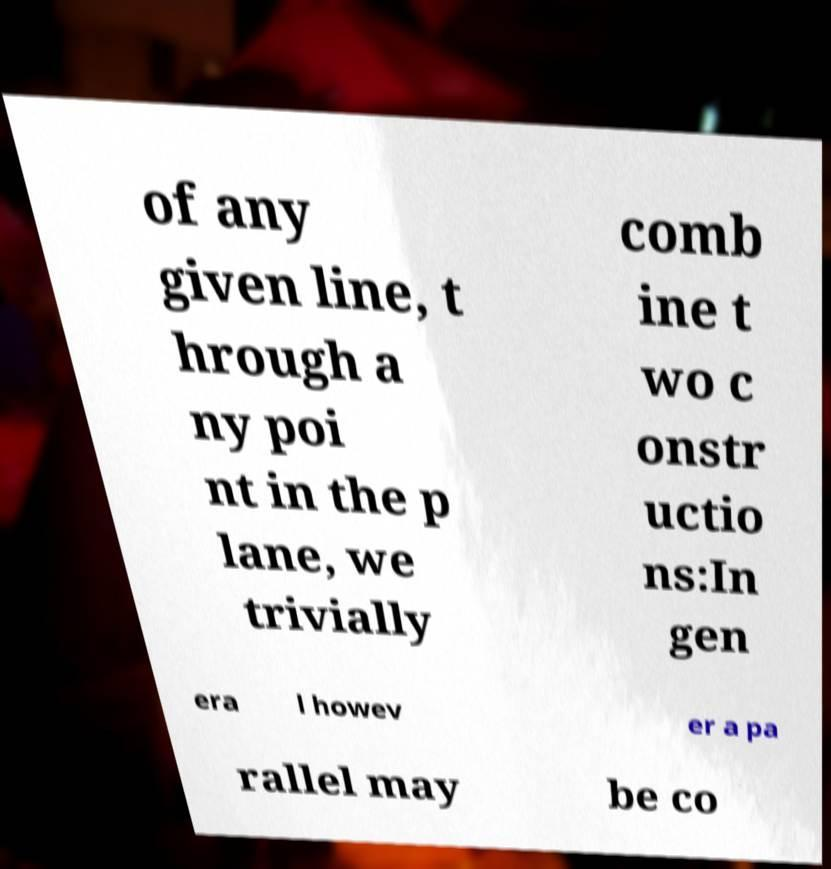Could you assist in decoding the text presented in this image and type it out clearly? of any given line, t hrough a ny poi nt in the p lane, we trivially comb ine t wo c onstr uctio ns:In gen era l howev er a pa rallel may be co 